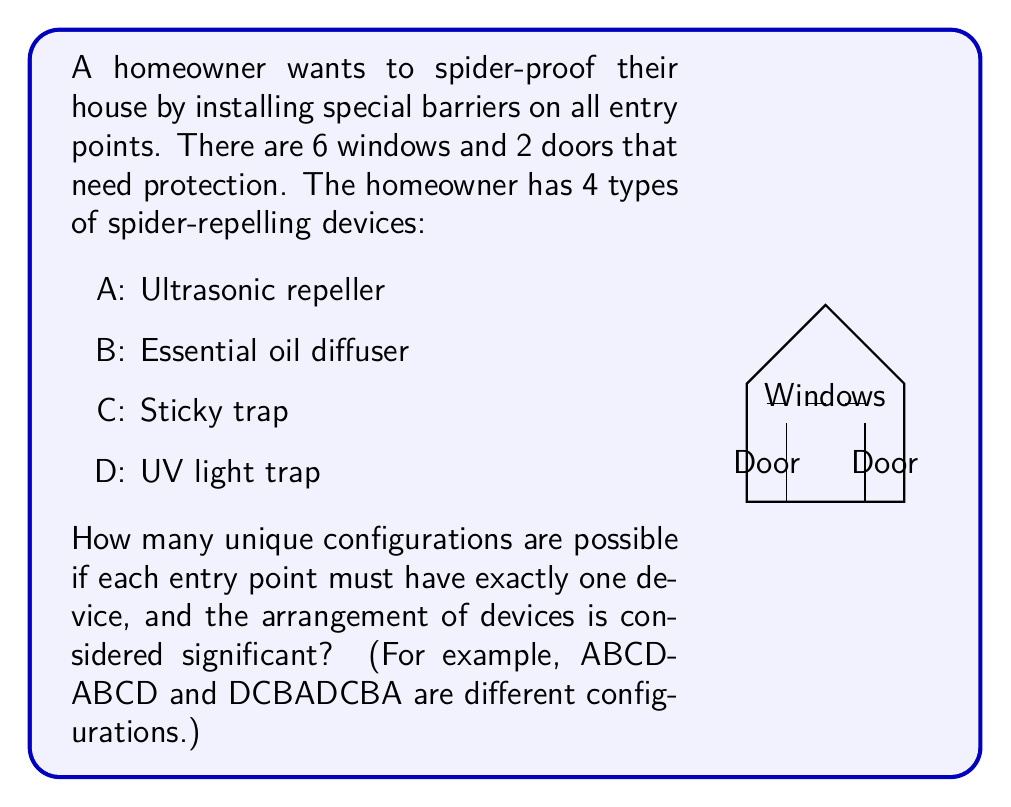Can you solve this math problem? Let's approach this step-by-step using permutation groups:

1) We have 8 entry points (6 windows + 2 doors) and 4 types of devices.

2) This is a permutation with repetition problem, as we can use each device type multiple times.

3) For each entry point, we have 4 choices of devices. This is true for all 8 entry points independently.

4) In permutation group theory, this scenario is represented by the direct product of 8 cyclic groups of order 4:

   $$G = C_4 \times C_4 \times C_4 \times C_4 \times C_4 \times C_4 \times C_4 \times C_4$$

5) The order (number of elements) of a direct product of groups is the product of the orders of the individual groups:

   $$|G| = |C_4| \times |C_4| \times |C_4| \times |C_4| \times |C_4| \times |C_4| \times |C_4| \times |C_4|$$

6) We know that $|C_4| = 4$ for each cyclic group of order 4.

7) Therefore, the total number of unique configurations is:

   $$|G| = 4 \times 4 \times 4 \times 4 \times 4 \times 4 \times 4 \times 4 = 4^8$$

8) Calculate $4^8$:

   $$4^8 = 65,536$$

Thus, there are 65,536 unique configurations possible.
Answer: 65,536 